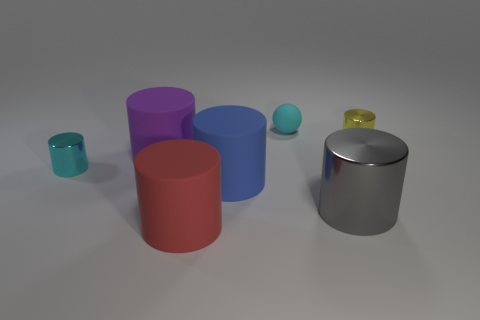What number of small things are either blue things or cyan matte balls?
Keep it short and to the point. 1. What size is the metallic cylinder that is the same color as the matte ball?
Provide a short and direct response. Small. There is a rubber object behind the small cylinder that is on the right side of the tiny cyan matte ball; what color is it?
Ensure brevity in your answer.  Cyan. Is the material of the blue cylinder the same as the small cylinder right of the large gray shiny object?
Offer a terse response. No. There is a cyan thing that is left of the big blue matte object; what is its material?
Offer a very short reply. Metal. Are there the same number of tiny metallic cylinders that are to the right of the red matte cylinder and cyan objects?
Offer a terse response. No. Is there any other thing that is the same size as the purple rubber thing?
Keep it short and to the point. Yes. There is a tiny cyan object that is in front of the tiny shiny cylinder that is right of the tiny cyan shiny cylinder; what is its material?
Offer a terse response. Metal. What is the shape of the small thing that is both in front of the cyan rubber sphere and on the left side of the big metal cylinder?
Your answer should be very brief. Cylinder. What size is the cyan shiny object that is the same shape as the yellow metallic object?
Your answer should be compact. Small. 